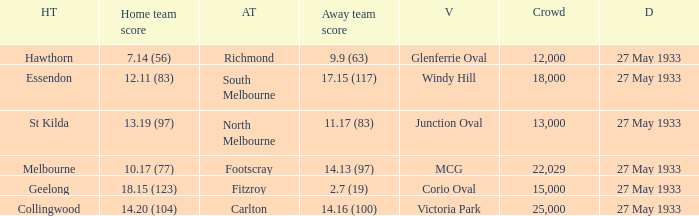In the match where the away team scored 2.7 (19), how many peopel were in the crowd? 15000.0. 